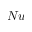Convert formula to latex. <formula><loc_0><loc_0><loc_500><loc_500>N u</formula> 